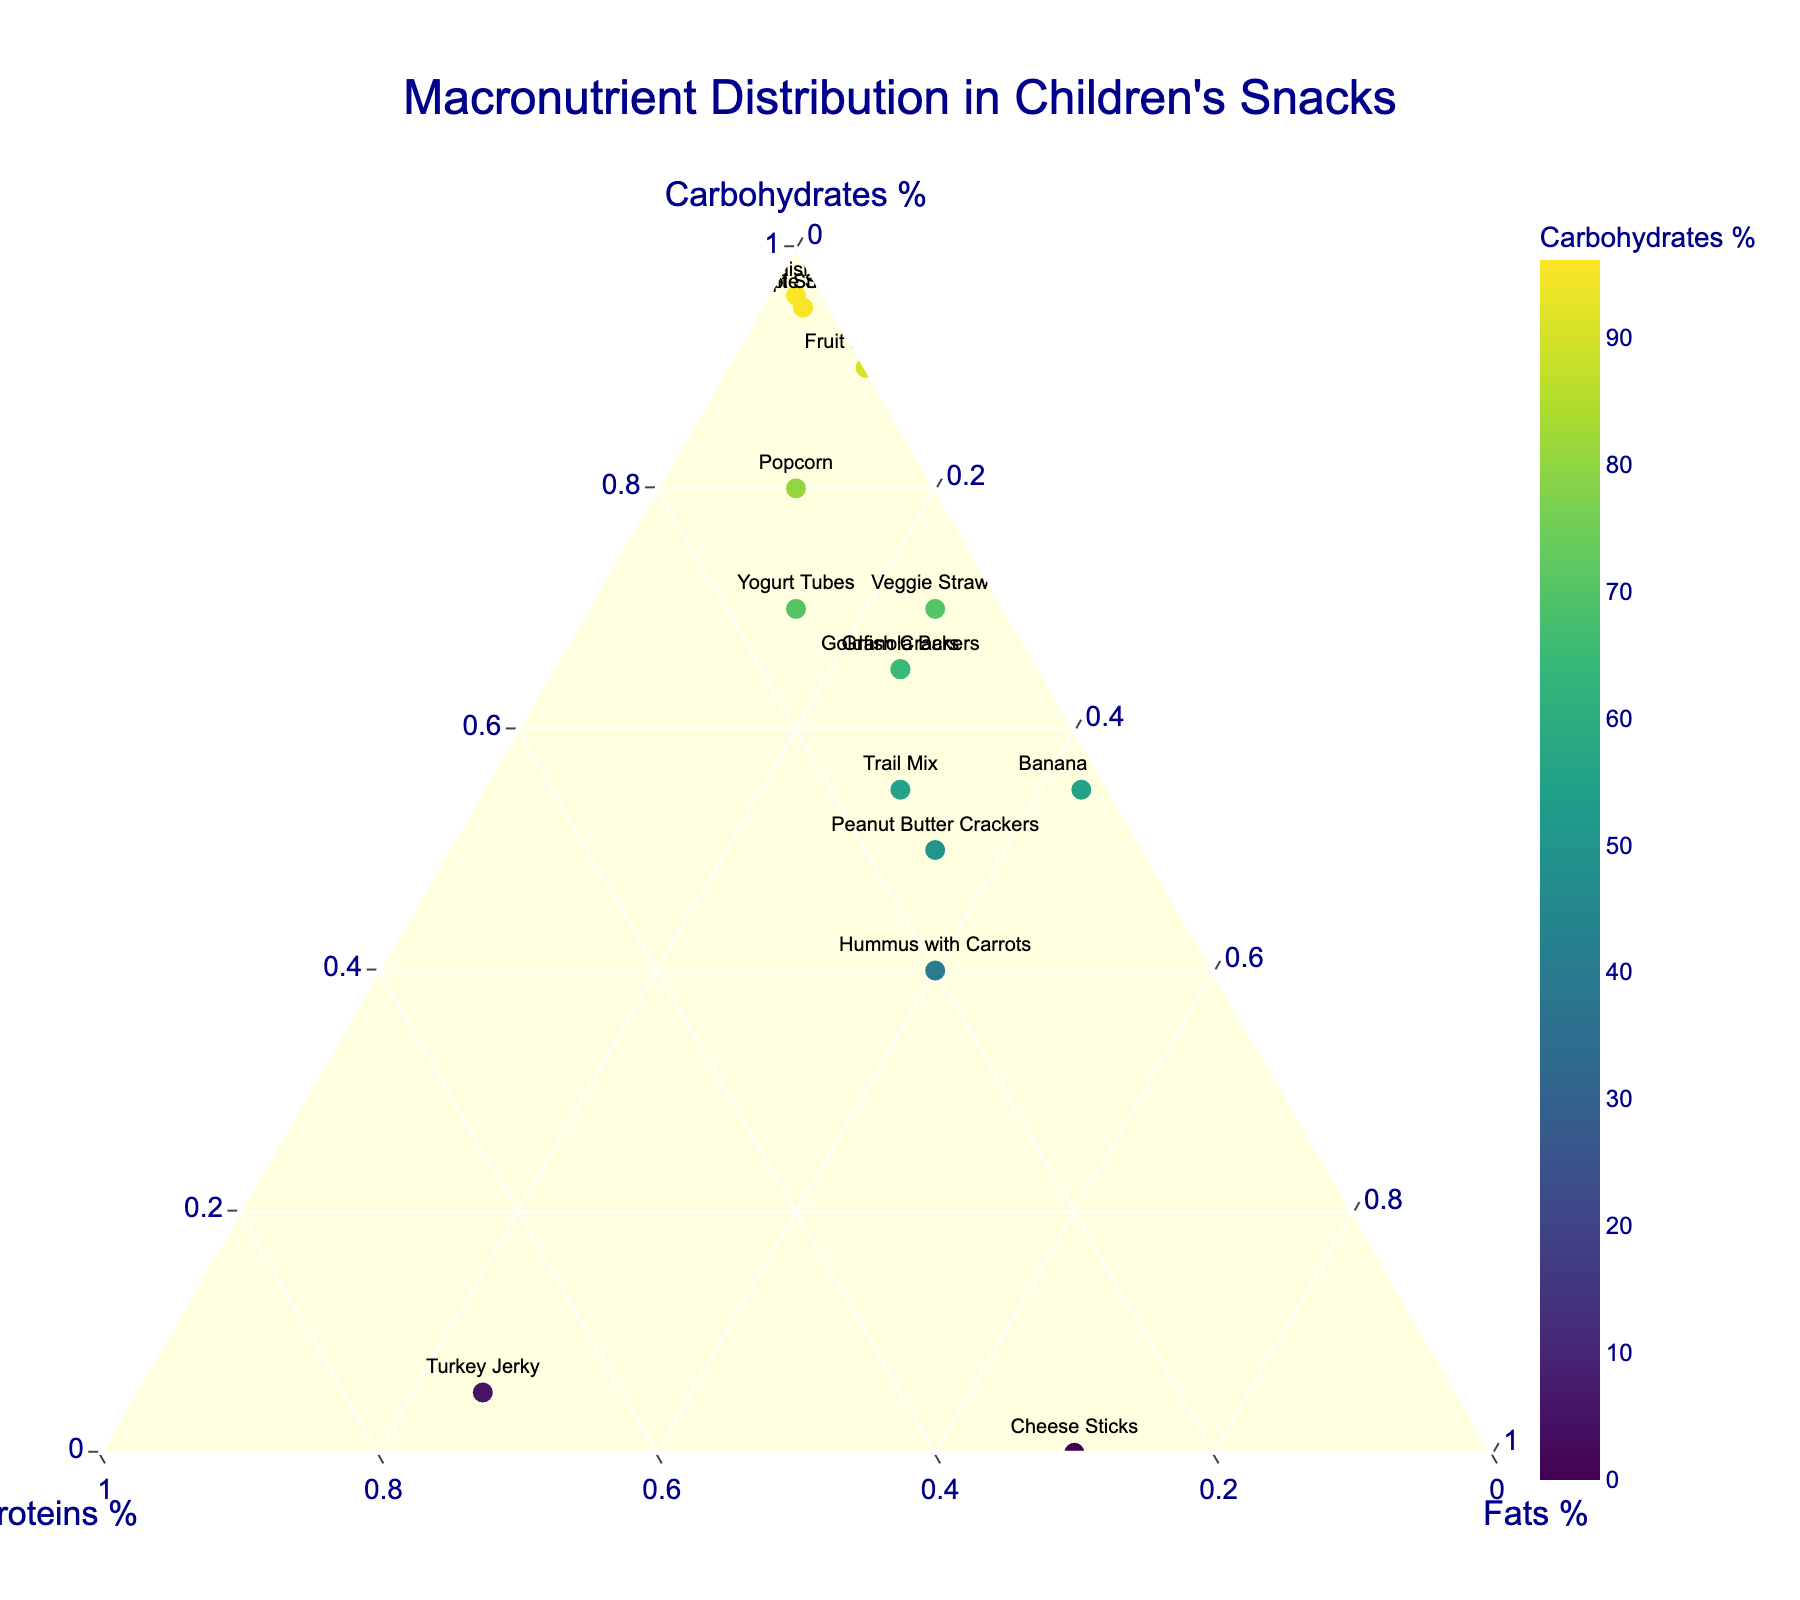What is the title of the plot? The plot title is displayed at the top center of the figure. It reads "Macronutrient Distribution in Children's Snacks".
Answer: Macronutrient Distribution in Children's Snacks Which axis represents the percentage of Proteins? On a ternary plot, the axes are labeled along each point of the ternary triangle. The axis labeled "Proteins %" indicates the percentage of proteins.
Answer: Proteins % Which snack has the highest percentage of carbohydrates? Observe the plot for the data point closest to the Carbohydrates axis maximum (top corner of the triangle). The snack closest to this point is "Raisins".
Answer: Raisins How many snacks contain exactly 10% Proteins? Look for data points on the ternary plot that align with the 10% mark on the Proteins axis. There are three such points corresponding to "Goldfish Crackers", "Granola Bars", and "Popcorn".
Answer: 3 Is "Cheese Sticks" high in proteins or fats? Identify the placement of "Cheese Sticks" on the ternary plot. It is near the corner representing the maximum of the Fats axis, indicating it is high in fats.
Answer: Fats Which snack has a combination of Carbohydrates, Proteins, and Fats closest to equal proportions? Evaluate the points on the ternary plot that are closest to the center of the plot. "Hummus with Carrots" is near the center, indicating its macronutrient distribution is most balanced.
Answer: Hummus with Carrots Compare the Carbohydrate content between "Fruit Roll-Ups" and "Banana Chips". Which has more? Locate "Fruit Roll-Ups" and "Banana Chips" on the ternary plot. "Fruit Roll-Ups" is near the top (close to Carbohydrates axis maximum), while "Banana Chips" is lower. "Fruit Roll-Ups" has more carbohydrates.
Answer: Fruit Roll-Ups Which two snacks have exactly 2% Proteins? Locate the data points on the plot that align with the 2% mark on the Proteins axis. The snacks are "Apple Slices" and "Raisins".
Answer: Apple Slices and Raisins Is "Turkey Jerky" higher in Proteins or Carbohydrates? Identify the placement of "Turkey Jerky" on the plot. It is near the corner representing the maximum of the Proteins axis and far from the Carbohydrates axis, indicating it is higher in proteins.
Answer: Proteins 